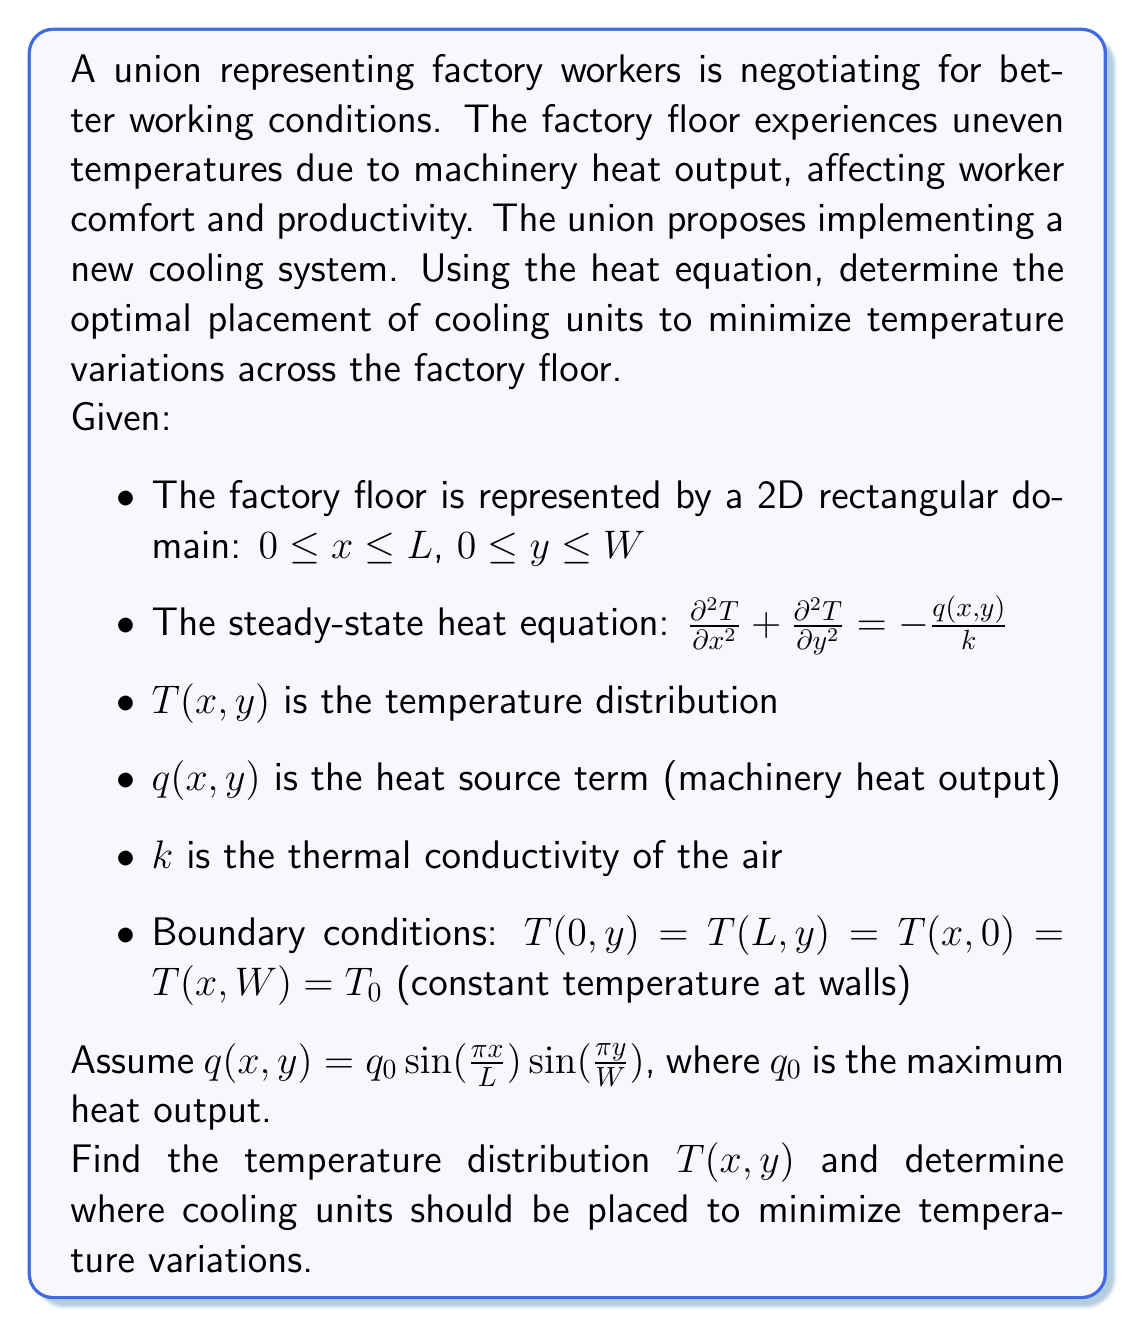Can you answer this question? To solve this problem, we'll follow these steps:

1) First, we need to solve the steady-state heat equation with the given boundary conditions and heat source term.

2) The general form of the solution will be:

   $T(x,y) = T_p(x,y) + T_h(x,y)$

   where $T_p$ is a particular solution and $T_h$ is the homogeneous solution.

3) For the particular solution, we can use the method of separation of variables. Given the form of $q(x,y)$, we can assume:

   $T_p(x,y) = A \sin(\frac{\pi x}{L}) \sin(\frac{\pi y}{W})$

4) Substituting this into the heat equation:

   $-A(\frac{\pi}{L})^2 \sin(\frac{\pi x}{L}) \sin(\frac{\pi y}{W}) - A(\frac{\pi}{W})^2 \sin(\frac{\pi x}{L}) \sin(\frac{\pi y}{W}) = -\frac{q_0}{k} \sin(\frac{\pi x}{L}) \sin(\frac{\pi y}{W})$

5) Solving for A:

   $A = \frac{q_0}{k[(\frac{\pi}{L})^2 + (\frac{\pi}{W})^2]}$

6) The homogeneous solution $T_h(x,y) = 0$ because the boundary conditions are all zero.

7) Therefore, the complete solution is:

   $T(x,y) = T_0 + \frac{q_0}{k[(\frac{\pi}{L})^2 + (\frac{\pi}{W})^2]} \sin(\frac{\pi x}{L}) \sin(\frac{\pi y}{W})$

8) To minimize temperature variations, cooling units should be placed where the temperature is highest. The maximum temperature occurs at the center of the factory floor $(x = L/2, y = W/2)$.

9) Secondary cooling units could be placed at local maxima, which occur at:

   $x = \frac{L}{2}, \frac{3L}{2}, \frac{5L}{2}, ...$
   $y = \frac{W}{2}, \frac{3W}{2}, \frac{5W}{2}, ...$

   within the bounds of the factory floor.
Answer: The optimal placement for cooling units is at the center of the factory floor $(x = L/2, y = W/2)$, with secondary units at local maxima $(x = \frac{nL}{2}, y = \frac{mW}{2})$ for odd integers $n$ and $m$, within the bounds of the floor. This placement will most effectively minimize temperature variations across the factory floor. 